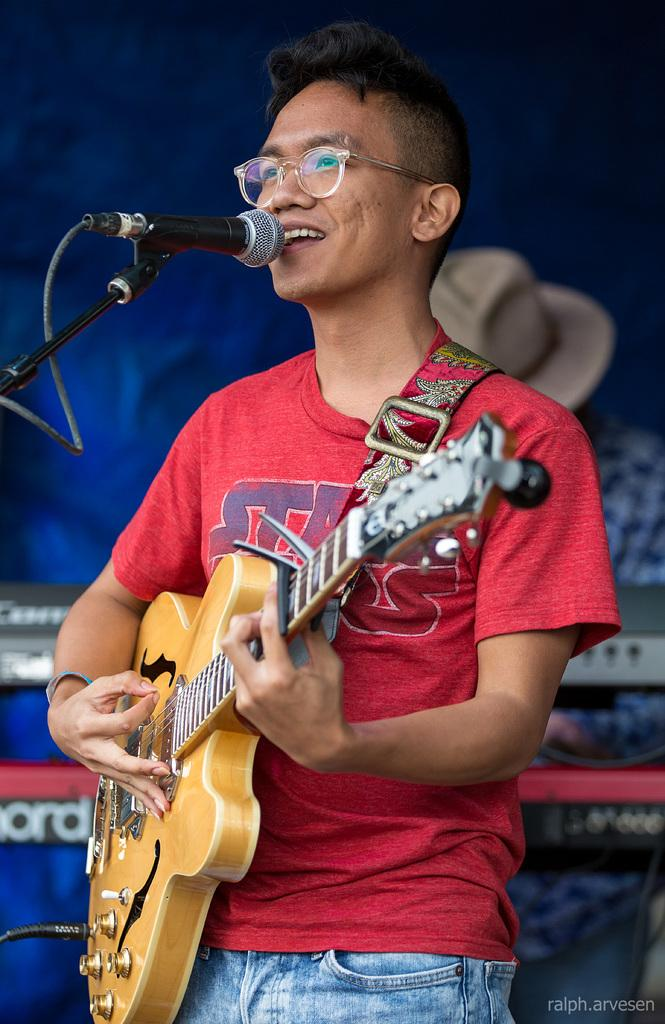What is the main subject of the image? There is a person standing in the center of the image. What is the person holding in the image? The person is holding a guitar. What is the person doing with the guitar? The person is playing the guitar. What is the person doing while playing the guitar? The person is singing on a microphone. What type of lock can be seen on the guitar in the image? There is no lock present on the guitar in the image. What is the taste of the person's singing in the image? The taste of the person's singing cannot be determined from the image, as taste is a sensory experience related to food and drink. 